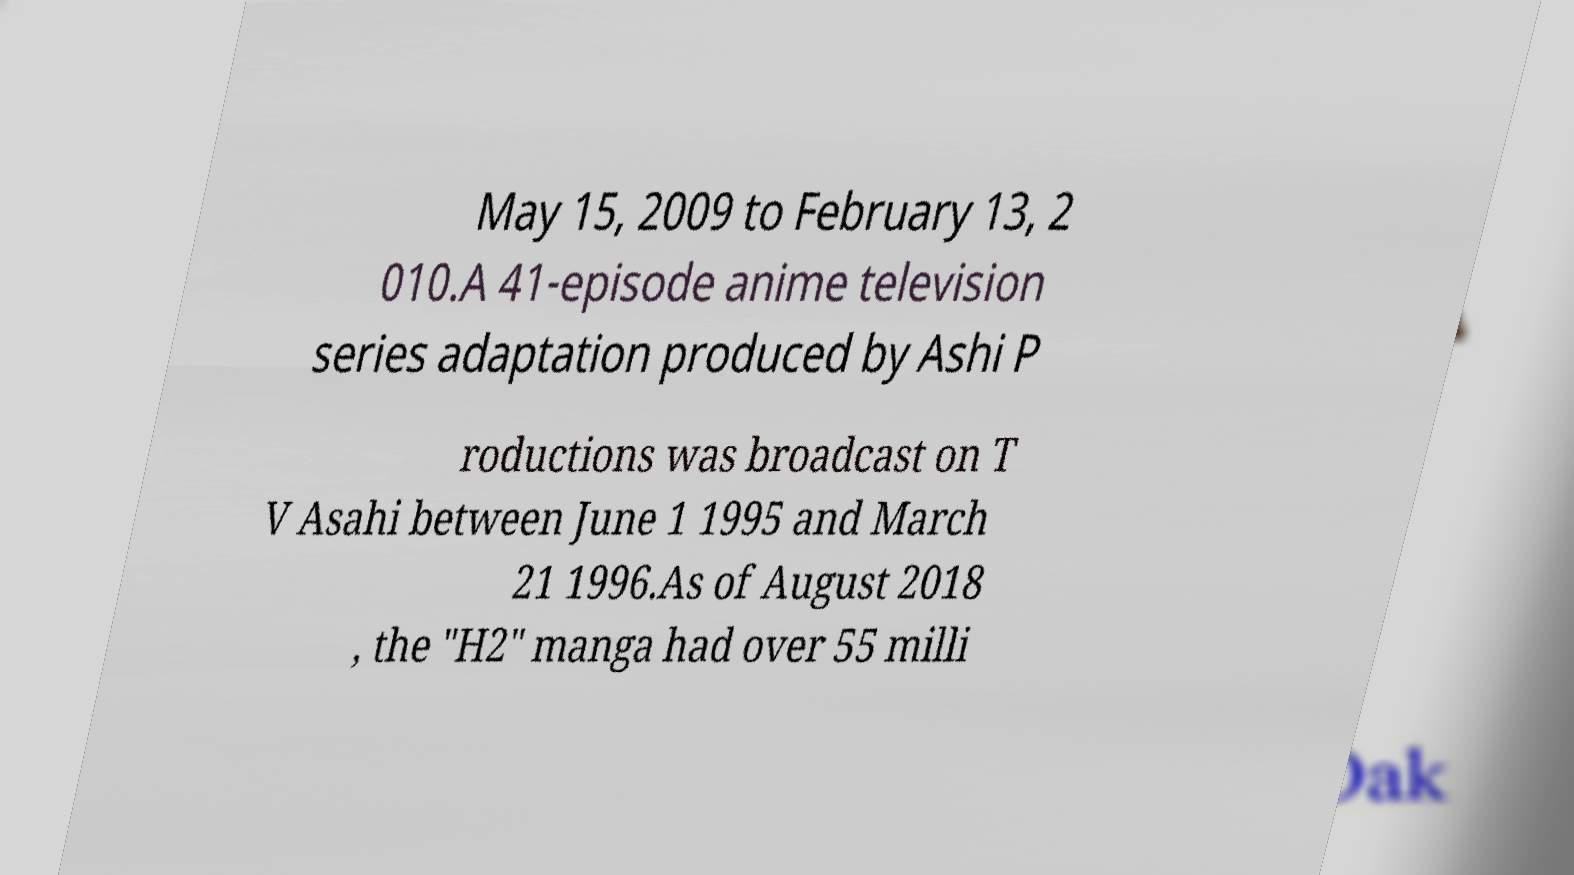I need the written content from this picture converted into text. Can you do that? May 15, 2009 to February 13, 2 010.A 41-episode anime television series adaptation produced by Ashi P roductions was broadcast on T V Asahi between June 1 1995 and March 21 1996.As of August 2018 , the "H2" manga had over 55 milli 